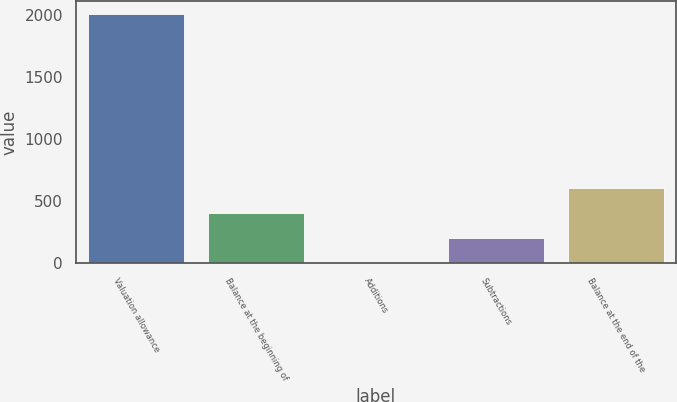Convert chart. <chart><loc_0><loc_0><loc_500><loc_500><bar_chart><fcel>Valuation allowance<fcel>Balance at the beginning of<fcel>Additions<fcel>Subtractions<fcel>Balance at the end of the<nl><fcel>2013<fcel>402.93<fcel>0.41<fcel>201.67<fcel>604.19<nl></chart> 